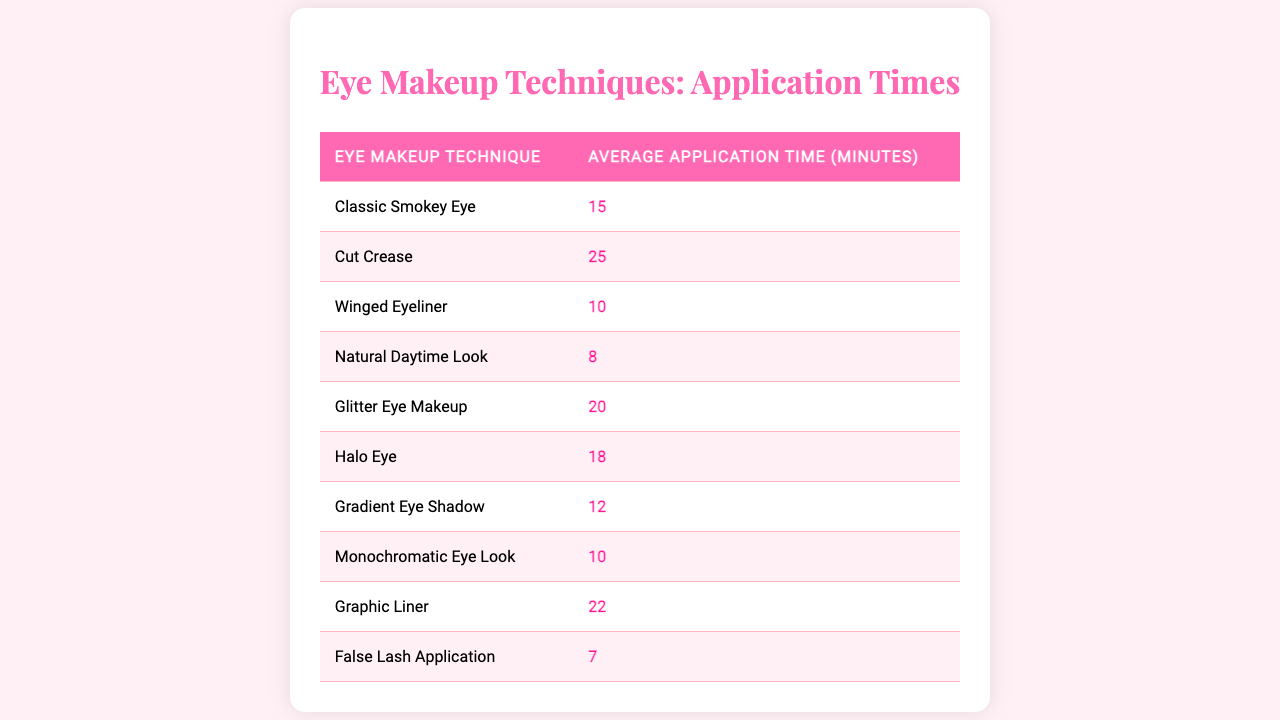What is the average application time for a Natural Daytime Look? The table indicates that the average application time for a Natural Daytime Look is 8 minutes.
Answer: 8 minutes Which eye makeup technique takes the longest to apply? By examining the table, the Cut Crease has the longest application time at 25 minutes.
Answer: Cut Crease What is the average application time for all eye makeup techniques listed? To find the average, sum the application times (15 + 25 + 10 + 8 + 20 + 18 + 12 + 10 + 22 + 7 =  147) and divide by the number of techniques (10), giving an average of 14.7 minutes.
Answer: 14.7 minutes Is the average application time for False Lash Application greater than 15 minutes? The average application time for False Lash Application is 7 minutes, which is less than 15 minutes. Thus, the statement is false.
Answer: No How much longer does it take to apply a Winged Eyeliner compared to a Natural Daytime Look? The application time for Winged Eyeliner is 10 minutes while for Natural Daytime Look is 8 minutes. The difference is 10 - 8 = 2 minutes.
Answer: 2 minutes Which techniques have application times of 20 minutes or more? From the table, the techniques with application times of 20 minutes or more are Cut Crease (25 minutes), Glitter Eye Makeup (20 minutes), and Graphic Liner (22 minutes).
Answer: Cut Crease, Glitter Eye Makeup, Graphic Liner If I were to apply a Classic Smokey Eye and a Halo Eye back-to-back, how long would that take in total? The application time for Classic Smokey Eye is 15 minutes and for Halo Eye is 18 minutes. The total time is 15 + 18 = 33 minutes.
Answer: 33 minutes What is the median application time among all the eye makeup techniques? Arranging the application times in ascending order: 7, 8, 10, 10, 12, 15, 18, 20, 22, 25, the median (middle value) is the average of the 5th and 6th values, which are 15 and 18, so (15 + 18) / 2 = 16.5 minutes.
Answer: 16.5 minutes How many techniques take less than 15 minutes to apply? The techniques with application times less than 15 minutes are Natural Daytime Look (8), Winged Eyeliner (10), Gradient Eye Shadow (12), and False Lash Application (7), totaling 4 techniques.
Answer: 4 techniques Is the application time for a Glitter Eye Makeup more than the average of all techniques? The average time is calculated as 14.7 minutes, and Glitter Eye Makeup takes 20 minutes, which is more than the average. Thus, the statement is true.
Answer: Yes 